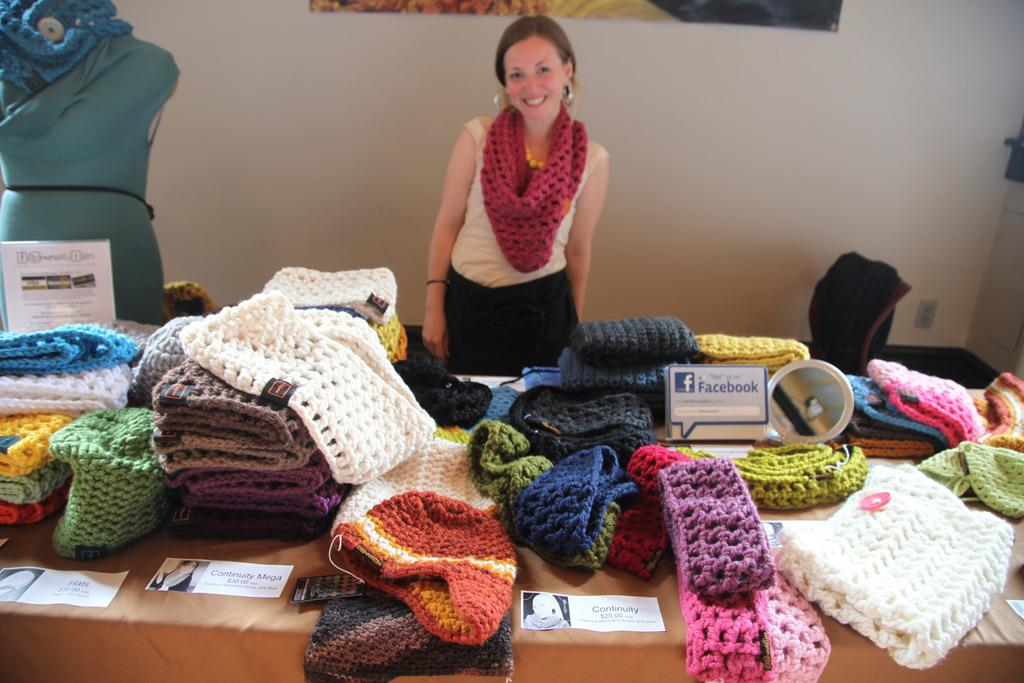Who is present in the image? There is a woman in the image. What items can be seen on the table in the image? There are woolen clothes on a table in the image. What object is located on the left side of the image? There is a mannequin on the left side of the image. What can be seen in the background of the image? There is a wall in the background of the image. Can you tell me how many cabbages are on the boat in the image? There is no boat or cabbage present in the image. 